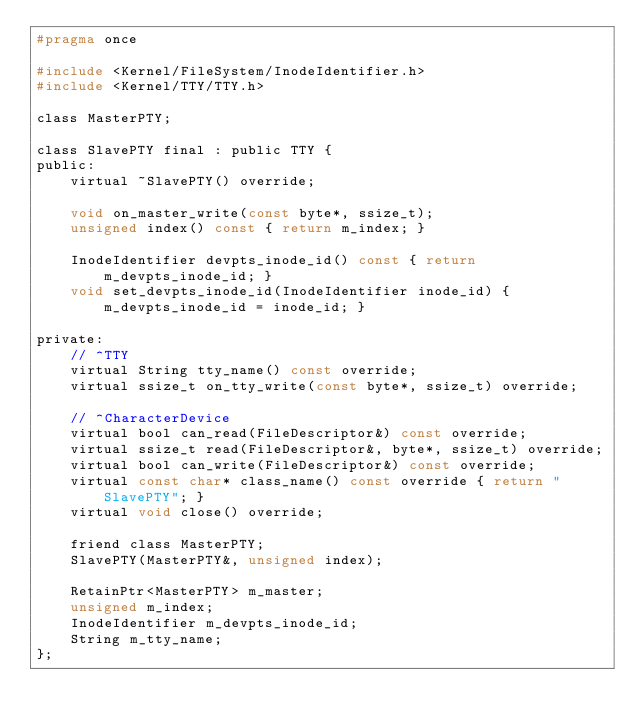<code> <loc_0><loc_0><loc_500><loc_500><_C_>#pragma once

#include <Kernel/FileSystem/InodeIdentifier.h>
#include <Kernel/TTY/TTY.h>

class MasterPTY;

class SlavePTY final : public TTY {
public:
    virtual ~SlavePTY() override;

    void on_master_write(const byte*, ssize_t);
    unsigned index() const { return m_index; }

    InodeIdentifier devpts_inode_id() const { return m_devpts_inode_id; }
    void set_devpts_inode_id(InodeIdentifier inode_id) { m_devpts_inode_id = inode_id; }

private:
    // ^TTY
    virtual String tty_name() const override;
    virtual ssize_t on_tty_write(const byte*, ssize_t) override;

    // ^CharacterDevice
    virtual bool can_read(FileDescriptor&) const override;
    virtual ssize_t read(FileDescriptor&, byte*, ssize_t) override;
    virtual bool can_write(FileDescriptor&) const override;
    virtual const char* class_name() const override { return "SlavePTY"; }
    virtual void close() override;

    friend class MasterPTY;
    SlavePTY(MasterPTY&, unsigned index);

    RetainPtr<MasterPTY> m_master;
    unsigned m_index;
    InodeIdentifier m_devpts_inode_id;
    String m_tty_name;
};

</code> 